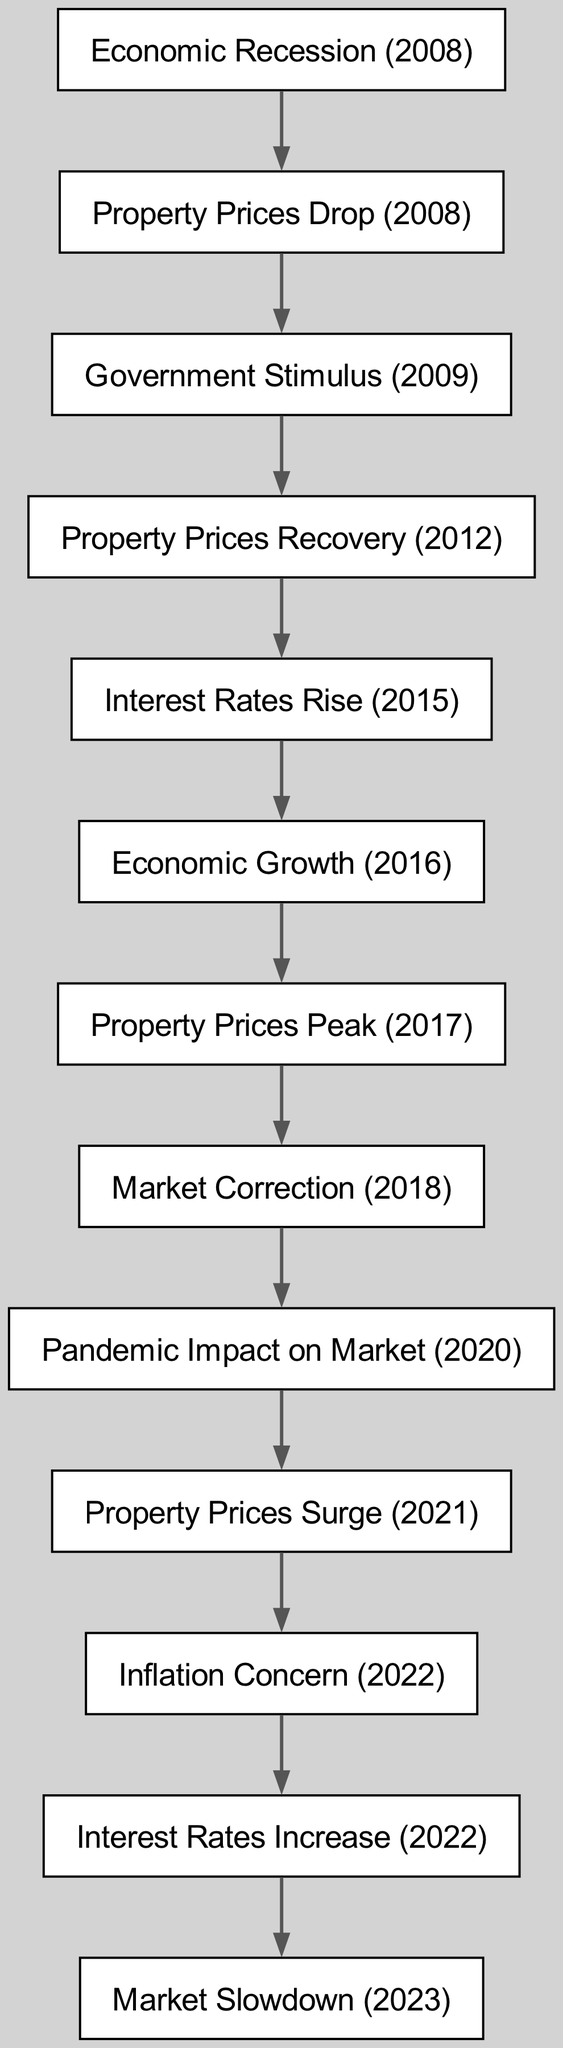What caused the Property Prices Drop in 2008? The diagram shows that the Economic Recession in 2008 led to the Property Prices Drop in the same year, indicating a direct relationship.
Answer: Economic Recession (2008) What happened after Government Stimulus in 2009? The diagram indicates that after the Government Stimulus in 2009, there was a Property Prices Recovery in 2012, showing a sequential effect on property prices.
Answer: Property Prices Recovery (2012) How many nodes are present in the diagram? By counting all distinct events listed in the diagram, the total number of nodes present is 12.
Answer: 12 What is the relationship between Interest Rates Rise in 2015 and Economic Growth in 2016? According to the directed graph, Interest Rates Rise in 2015 is a precursor to Economic Growth in 2016, meaning the rise in interest rates played a role in facilitating economic growth.
Answer: Preceding event What initiated the Market Slowdown in 2023? The diagram shows that the Interest Rates Increase in 2022 led to the Market Slowdown in 2023, establishing a cause-effect relationship between the increase in interest rates and the slowdown of the market.
Answer: Interest Rates Increase (2022) In which year did Property Prices peak? From the diagram, the Property Prices reached their peak in 2017, as depicted in the flow before the Market Correction in 2018.
Answer: Property Prices Peak (2017) How many significant price fluctuations are indicated in the diagram? By analyzing the edges indicating price changes, there are five significant price fluctuations captured in the nodes related to recovery, peak, drop, and surge.
Answer: Five What event follows the Market Correction in 2018? The directed graph indicates that the Pandemic Impact on Market in 2020 follows the Market Correction in 2018, showing a subsequent event in the timeline.
Answer: Pandemic Impact on Market (2020) 